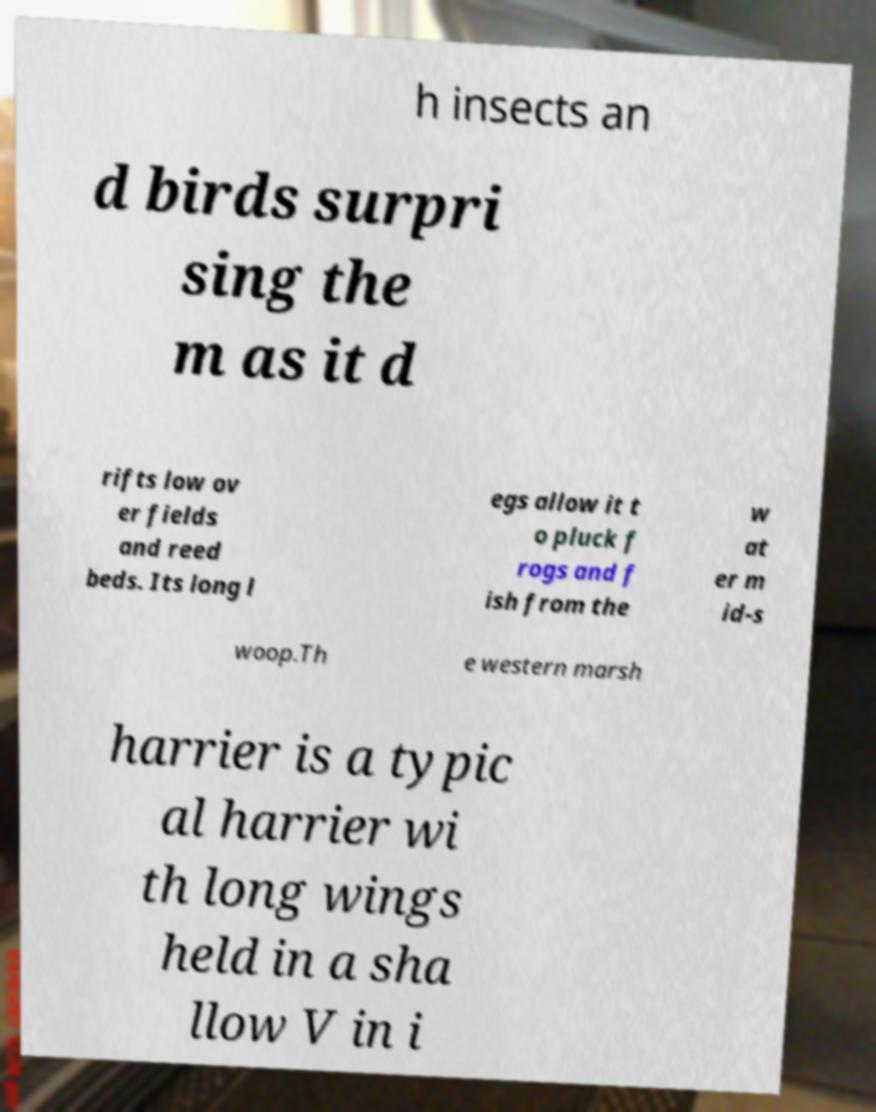There's text embedded in this image that I need extracted. Can you transcribe it verbatim? h insects an d birds surpri sing the m as it d rifts low ov er fields and reed beds. Its long l egs allow it t o pluck f rogs and f ish from the w at er m id-s woop.Th e western marsh harrier is a typic al harrier wi th long wings held in a sha llow V in i 